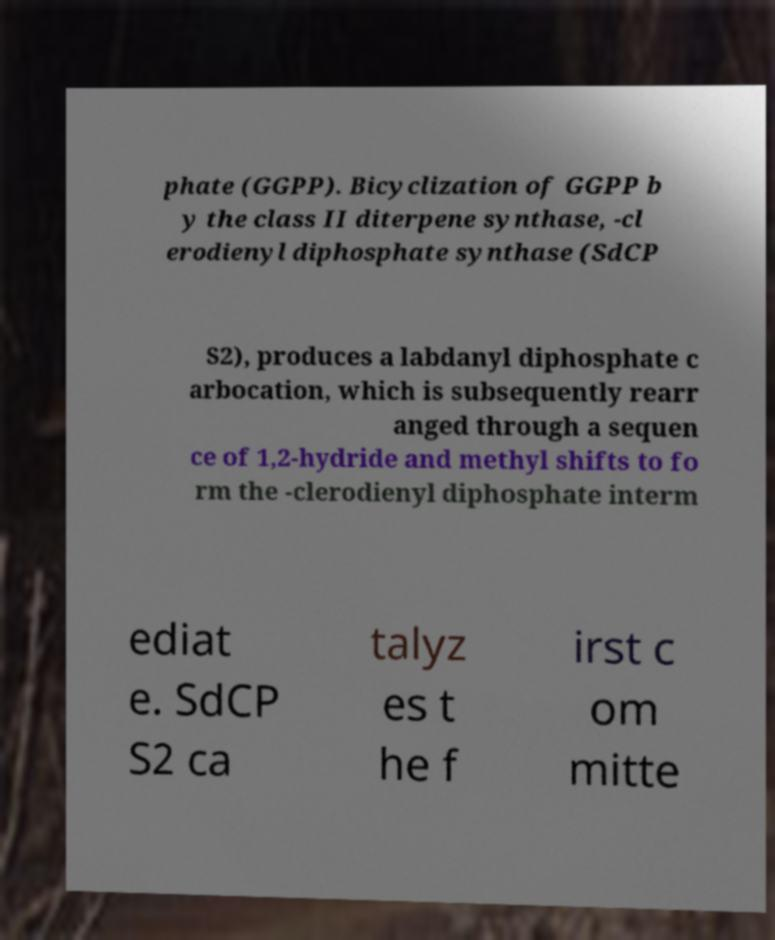For documentation purposes, I need the text within this image transcribed. Could you provide that? phate (GGPP). Bicyclization of GGPP b y the class II diterpene synthase, -cl erodienyl diphosphate synthase (SdCP S2), produces a labdanyl diphosphate c arbocation, which is subsequently rearr anged through a sequen ce of 1,2-hydride and methyl shifts to fo rm the -clerodienyl diphosphate interm ediat e. SdCP S2 ca talyz es t he f irst c om mitte 